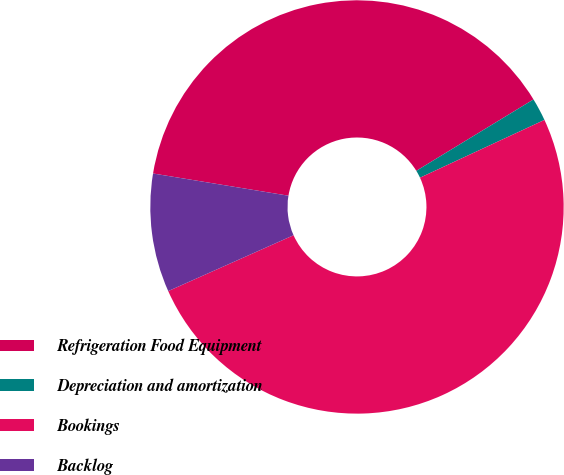Convert chart to OTSL. <chart><loc_0><loc_0><loc_500><loc_500><pie_chart><fcel>Refrigeration Food Equipment<fcel>Depreciation and amortization<fcel>Bookings<fcel>Backlog<nl><fcel>38.7%<fcel>1.79%<fcel>50.24%<fcel>9.26%<nl></chart> 